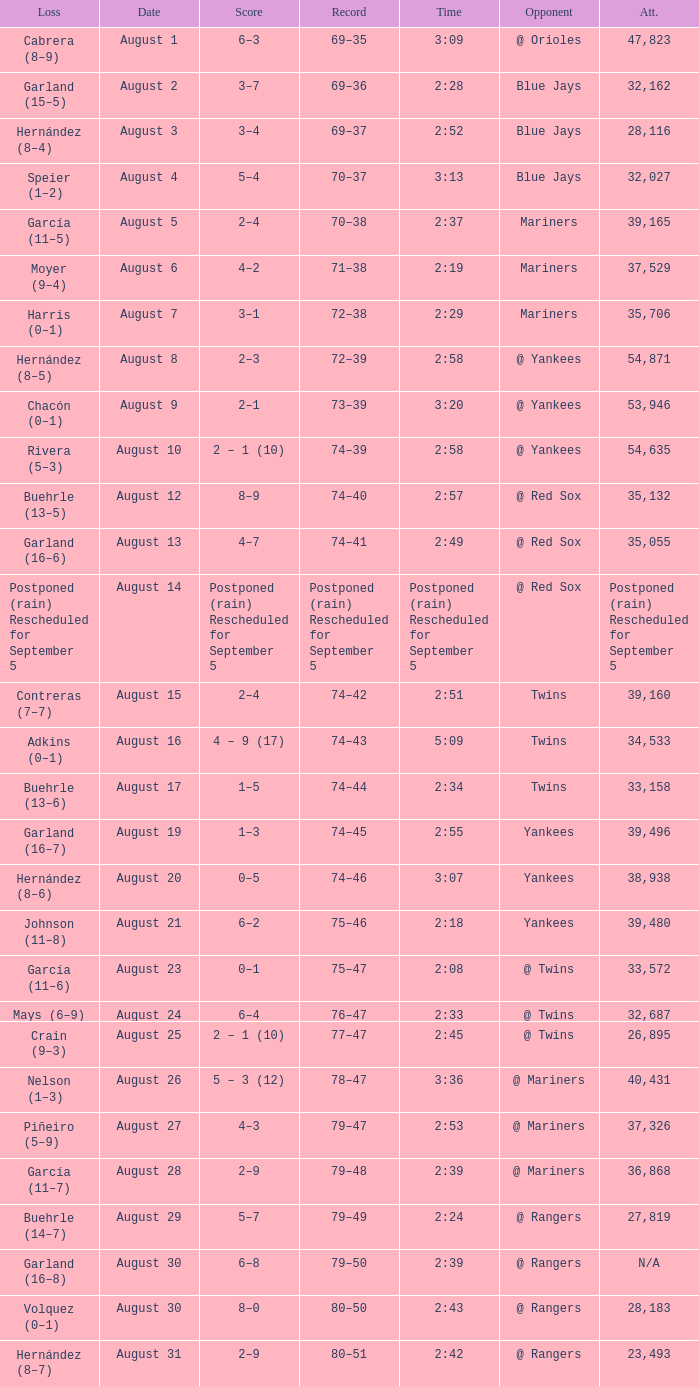Who lost on August 27? Piñeiro (5–9). Can you give me this table as a dict? {'header': ['Loss', 'Date', 'Score', 'Record', 'Time', 'Opponent', 'Att.'], 'rows': [['Cabrera (8–9)', 'August 1', '6–3', '69–35', '3:09', '@ Orioles', '47,823'], ['Garland (15–5)', 'August 2', '3–7', '69–36', '2:28', 'Blue Jays', '32,162'], ['Hernández (8–4)', 'August 3', '3–4', '69–37', '2:52', 'Blue Jays', '28,116'], ['Speier (1–2)', 'August 4', '5–4', '70–37', '3:13', 'Blue Jays', '32,027'], ['García (11–5)', 'August 5', '2–4', '70–38', '2:37', 'Mariners', '39,165'], ['Moyer (9–4)', 'August 6', '4–2', '71–38', '2:19', 'Mariners', '37,529'], ['Harris (0–1)', 'August 7', '3–1', '72–38', '2:29', 'Mariners', '35,706'], ['Hernández (8–5)', 'August 8', '2–3', '72–39', '2:58', '@ Yankees', '54,871'], ['Chacón (0–1)', 'August 9', '2–1', '73–39', '3:20', '@ Yankees', '53,946'], ['Rivera (5–3)', 'August 10', '2 – 1 (10)', '74–39', '2:58', '@ Yankees', '54,635'], ['Buehrle (13–5)', 'August 12', '8–9', '74–40', '2:57', '@ Red Sox', '35,132'], ['Garland (16–6)', 'August 13', '4–7', '74–41', '2:49', '@ Red Sox', '35,055'], ['Postponed (rain) Rescheduled for September 5', 'August 14', 'Postponed (rain) Rescheduled for September 5', 'Postponed (rain) Rescheduled for September 5', 'Postponed (rain) Rescheduled for September 5', '@ Red Sox', 'Postponed (rain) Rescheduled for September 5'], ['Contreras (7–7)', 'August 15', '2–4', '74–42', '2:51', 'Twins', '39,160'], ['Adkins (0–1)', 'August 16', '4 – 9 (17)', '74–43', '5:09', 'Twins', '34,533'], ['Buehrle (13–6)', 'August 17', '1–5', '74–44', '2:34', 'Twins', '33,158'], ['Garland (16–7)', 'August 19', '1–3', '74–45', '2:55', 'Yankees', '39,496'], ['Hernández (8–6)', 'August 20', '0–5', '74–46', '3:07', 'Yankees', '38,938'], ['Johnson (11–8)', 'August 21', '6–2', '75–46', '2:18', 'Yankees', '39,480'], ['García (11–6)', 'August 23', '0–1', '75–47', '2:08', '@ Twins', '33,572'], ['Mays (6–9)', 'August 24', '6–4', '76–47', '2:33', '@ Twins', '32,687'], ['Crain (9–3)', 'August 25', '2 – 1 (10)', '77–47', '2:45', '@ Twins', '26,895'], ['Nelson (1–3)', 'August 26', '5 – 3 (12)', '78–47', '3:36', '@ Mariners', '40,431'], ['Piñeiro (5–9)', 'August 27', '4–3', '79–47', '2:53', '@ Mariners', '37,326'], ['García (11–7)', 'August 28', '2–9', '79–48', '2:39', '@ Mariners', '36,868'], ['Buehrle (14–7)', 'August 29', '5–7', '79–49', '2:24', '@ Rangers', '27,819'], ['Garland (16–8)', 'August 30', '6–8', '79–50', '2:39', '@ Rangers', 'N/A'], ['Volquez (0–1)', 'August 30', '8–0', '80–50', '2:43', '@ Rangers', '28,183'], ['Hernández (8–7)', 'August 31', '2–9', '80–51', '2:42', '@ Rangers', '23,493']]} 